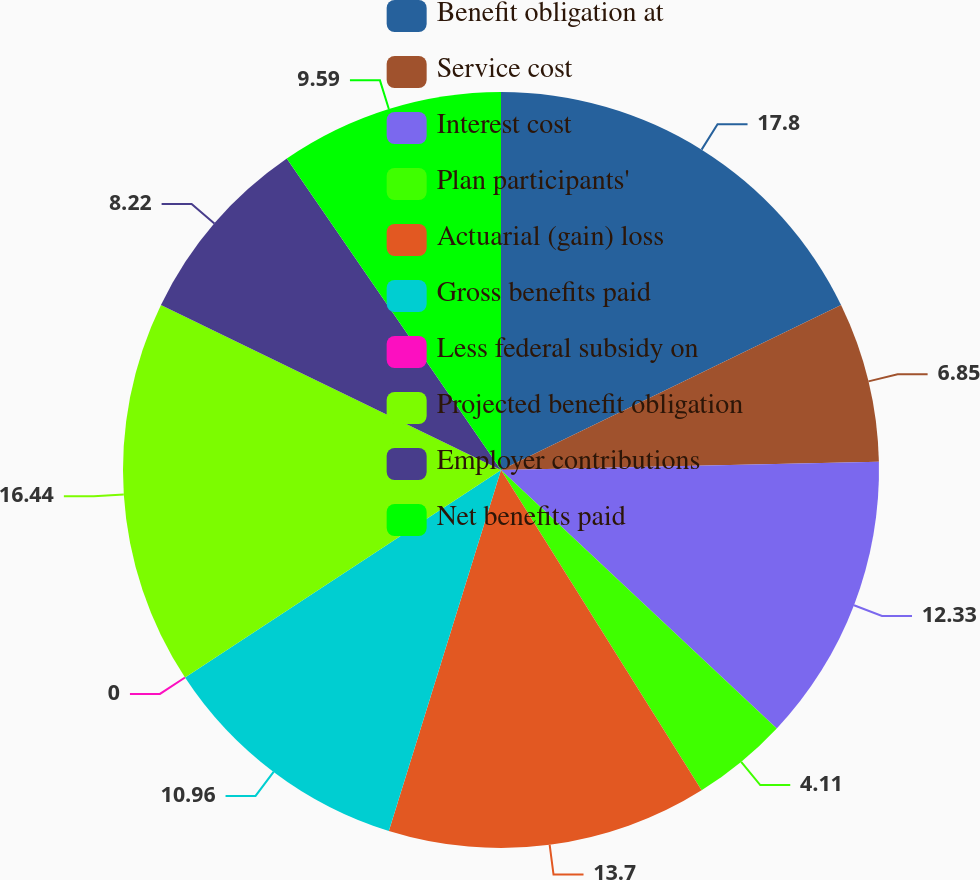Convert chart to OTSL. <chart><loc_0><loc_0><loc_500><loc_500><pie_chart><fcel>Benefit obligation at<fcel>Service cost<fcel>Interest cost<fcel>Plan participants'<fcel>Actuarial (gain) loss<fcel>Gross benefits paid<fcel>Less federal subsidy on<fcel>Projected benefit obligation<fcel>Employer contributions<fcel>Net benefits paid<nl><fcel>17.81%<fcel>6.85%<fcel>12.33%<fcel>4.11%<fcel>13.7%<fcel>10.96%<fcel>0.0%<fcel>16.44%<fcel>8.22%<fcel>9.59%<nl></chart> 